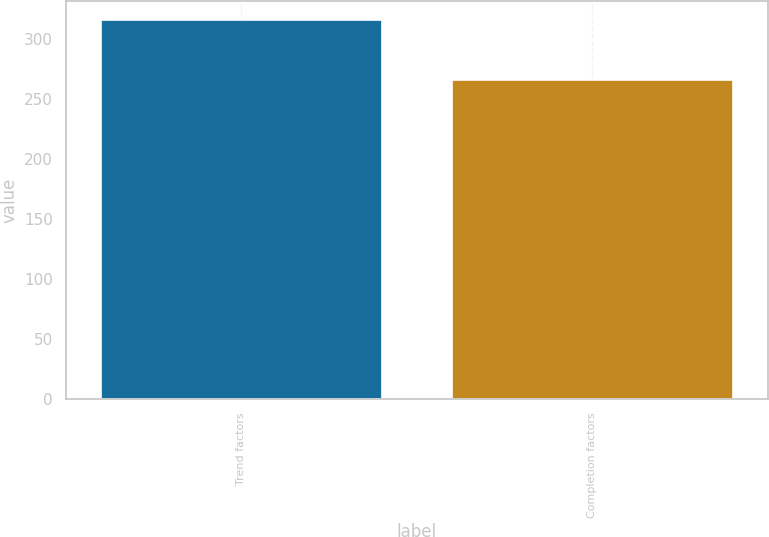<chart> <loc_0><loc_0><loc_500><loc_500><bar_chart><fcel>Trend factors<fcel>Completion factors<nl><fcel>316<fcel>266<nl></chart> 